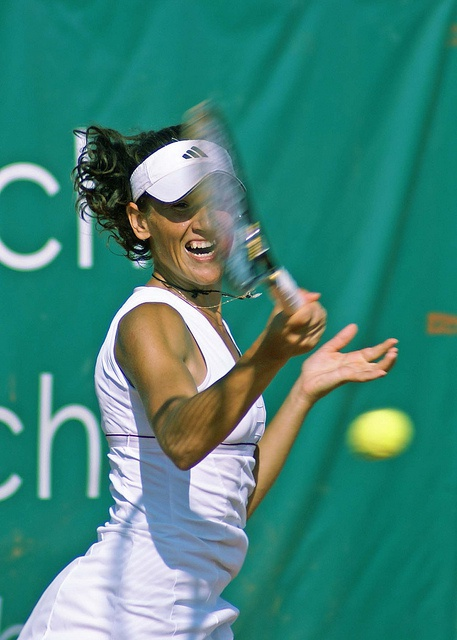Describe the objects in this image and their specific colors. I can see people in teal, lavender, olive, gray, and black tones, tennis racket in teal, gray, and darkgray tones, and sports ball in teal, khaki, green, and lightgreen tones in this image. 